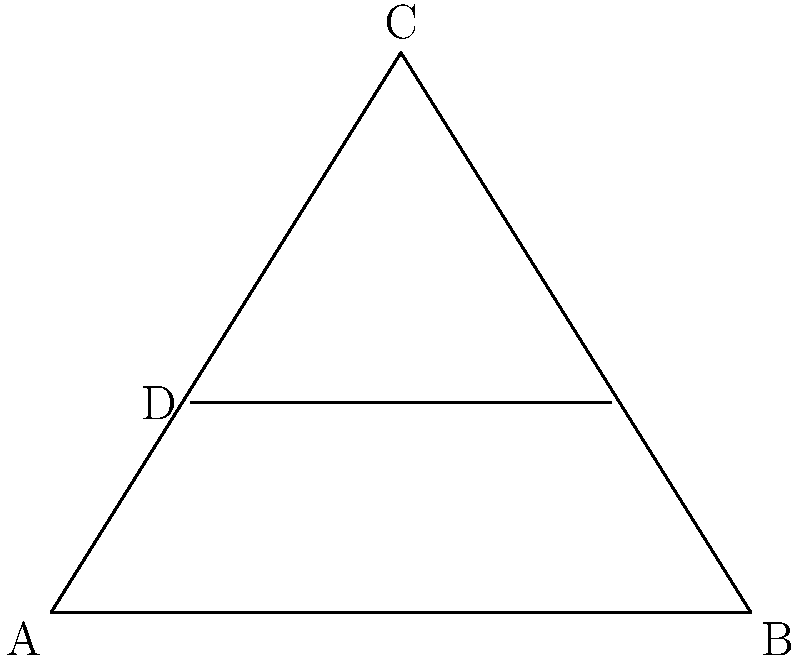In a meticulously crafted courtroom floor plan, a novelist has drawn intersecting lines that form congruent triangles. Given that triangle ACD is congruent to triangle BCE, and DE is parallel to AB, what is the ratio of AD to DB? Let's approach this step-by-step, as if we're unraveling a mystery in the courtroom:

1) First, we know that triangle ACD is congruent to triangle BCE. This means that all corresponding sides and angles are equal.

2) Given that DE is parallel to AB, we can apply the theorem of similar triangles. This theorem states that a line parallel to one side of a triangle divides the other two sides proportionally.

3) Let's focus on triangle ACB. DE is parallel to AB and intersects the other two sides of the triangle.

4) This creates two similar triangles: ADE and CDE.

5) The ratio of the sides of these similar triangles will be constant. Let's call this ratio $r$. So:

   $\frac{AD}{DC} = \frac{AE}{EC} = r$

6) We can also write: $\frac{AD}{DB} = \frac{AE}{EB}$

7) Now, remember that triangle ACD is congruent to triangle BCE. This means that AD = BE and DC = AE.

8) Substituting these into our ratio from step 5:

   $\frac{AD}{AE} = \frac{BE}{EC} = r$

9) But we know that $AD = BE$ (from step 7), so:

   $\frac{AD}{AE} = \frac{AD}{EC} = r$

10) This means that $AE = EC$, or in other words, point E is the midpoint of AC.

11) If E is the midpoint of AC, then $AE = EC = \frac{1}{2}AC$

12) Going back to our ratio from step 6:

    $\frac{AD}{DB} = \frac{AE}{EB} = \frac{\frac{1}{2}AC}{CB} = \frac{1}{2}$

Therefore, the ratio of AD to DB is 1:2 or 0.5:1.
Answer: $1:2$ 